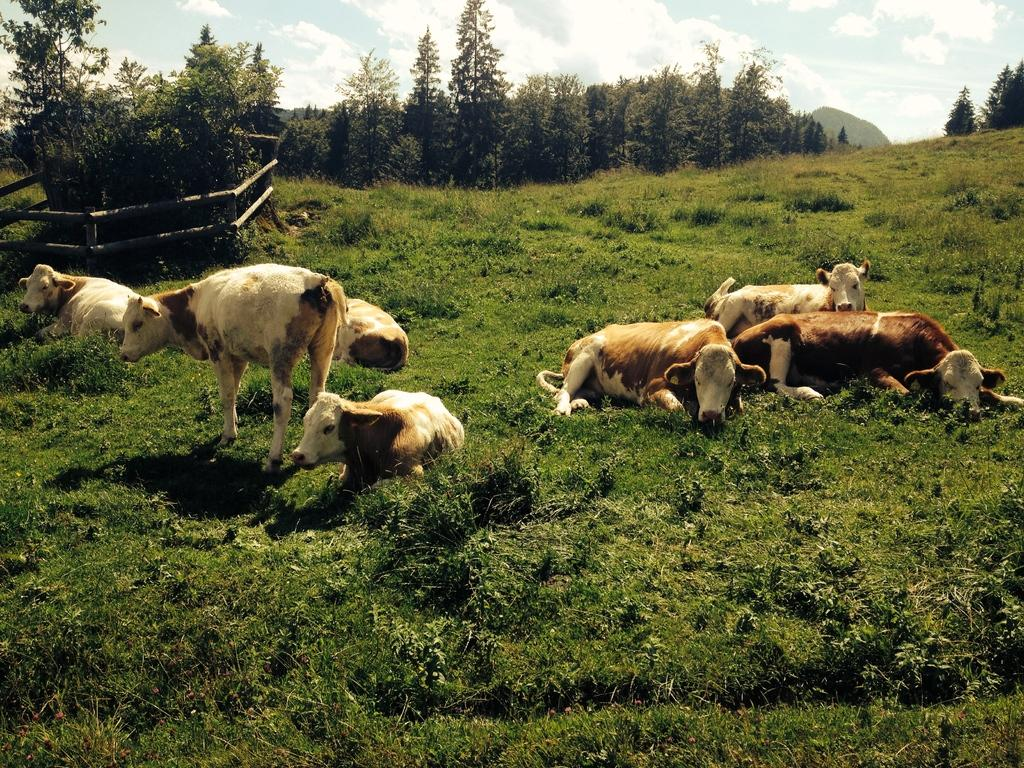What animals are present in the image? There is a herd of cows in the image. What is the cows' location in the image? The cows are on the grass in the image. What type of vegetation can be seen in the image? There are trees in the image. What is the barrier surrounding the cows in the image? There is a wooden fence in the image. What is visible in the background of the image? The sky is visible in the background of the image. What type of amusement can be seen in the image? There is no amusement present in the image; it features a herd of cows on the grass with trees and a wooden fence. What unit of measurement is used to determine the size of the cows in the image? There is no specific unit of measurement mentioned in the image, and the size of the cows cannot be determined from the image alone. 